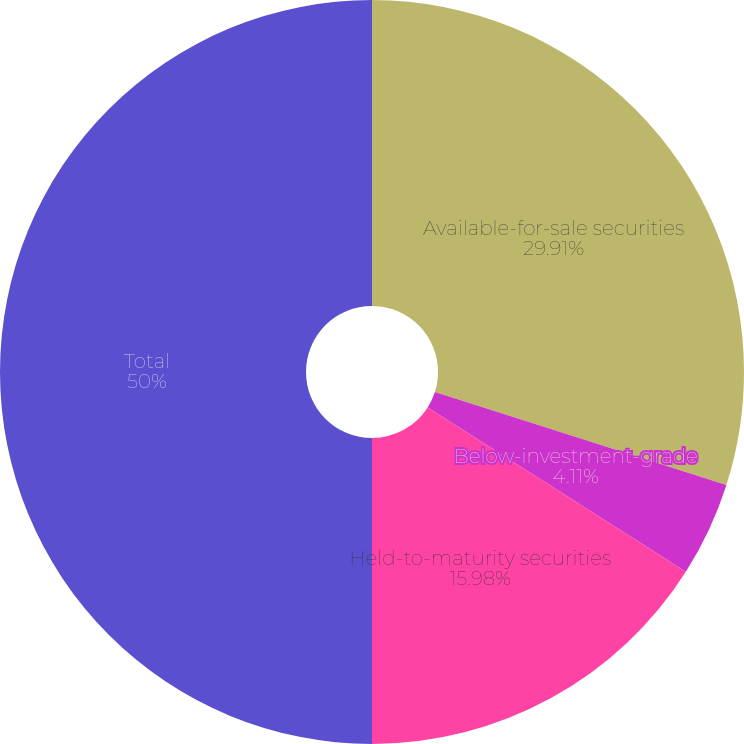Convert chart. <chart><loc_0><loc_0><loc_500><loc_500><pie_chart><fcel>Available-for-sale securities<fcel>Below-investment-grade<fcel>Held-to-maturity securities<fcel>Total<nl><fcel>29.91%<fcel>4.11%<fcel>15.98%<fcel>50.0%<nl></chart> 